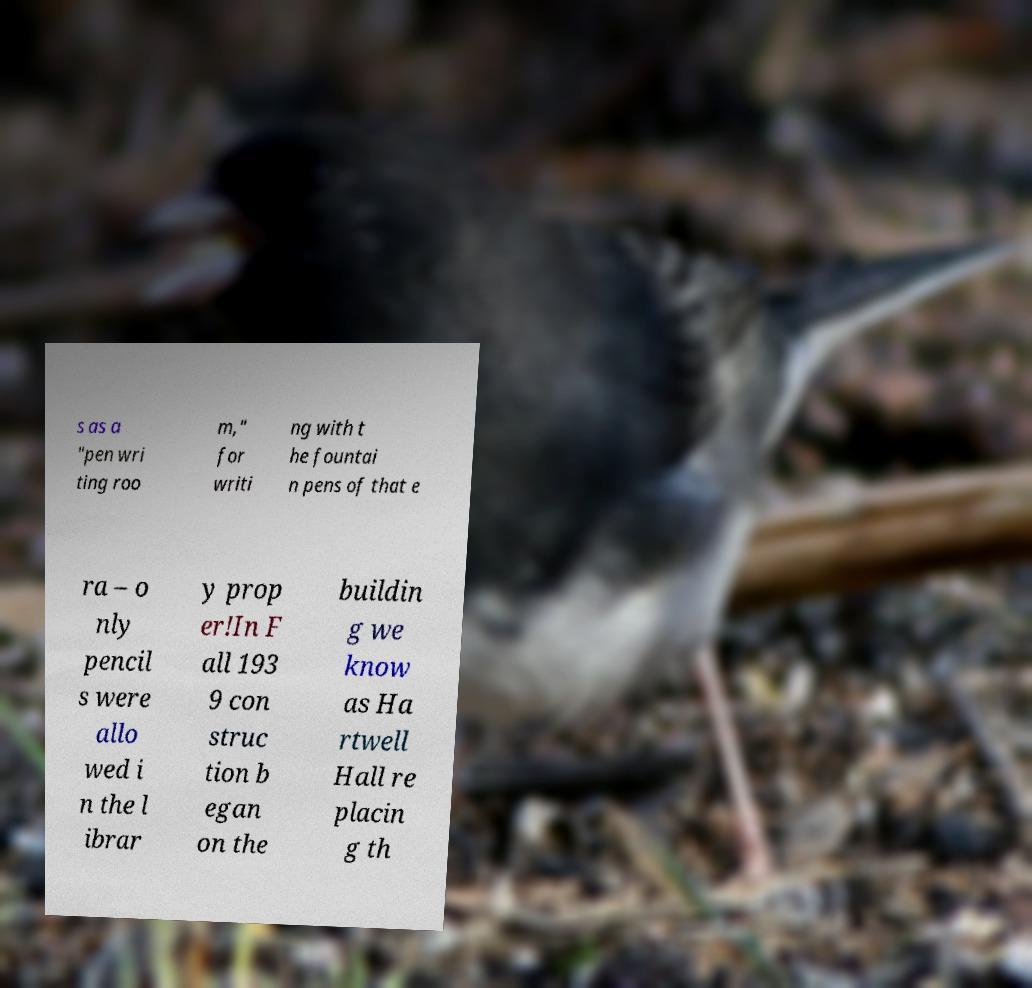What messages or text are displayed in this image? I need them in a readable, typed format. s as a "pen wri ting roo m," for writi ng with t he fountai n pens of that e ra – o nly pencil s were allo wed i n the l ibrar y prop er!In F all 193 9 con struc tion b egan on the buildin g we know as Ha rtwell Hall re placin g th 